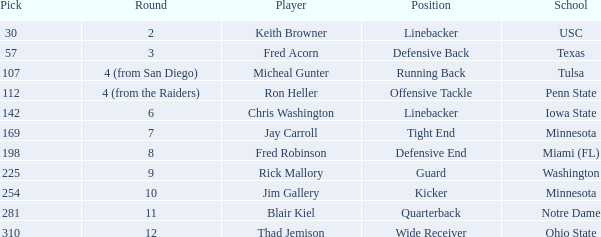Could you parse the entire table? {'header': ['Pick', 'Round', 'Player', 'Position', 'School'], 'rows': [['30', '2', 'Keith Browner', 'Linebacker', 'USC'], ['57', '3', 'Fred Acorn', 'Defensive Back', 'Texas'], ['107', '4 (from San Diego)', 'Micheal Gunter', 'Running Back', 'Tulsa'], ['112', '4 (from the Raiders)', 'Ron Heller', 'Offensive Tackle', 'Penn State'], ['142', '6', 'Chris Washington', 'Linebacker', 'Iowa State'], ['169', '7', 'Jay Carroll', 'Tight End', 'Minnesota'], ['198', '8', 'Fred Robinson', 'Defensive End', 'Miami (FL)'], ['225', '9', 'Rick Mallory', 'Guard', 'Washington'], ['254', '10', 'Jim Gallery', 'Kicker', 'Minnesota'], ['281', '11', 'Blair Kiel', 'Quarterback', 'Notre Dame'], ['310', '12', 'Thad Jemison', 'Wide Receiver', 'Ohio State']]} What is thad jemison's title? Wide Receiver. 